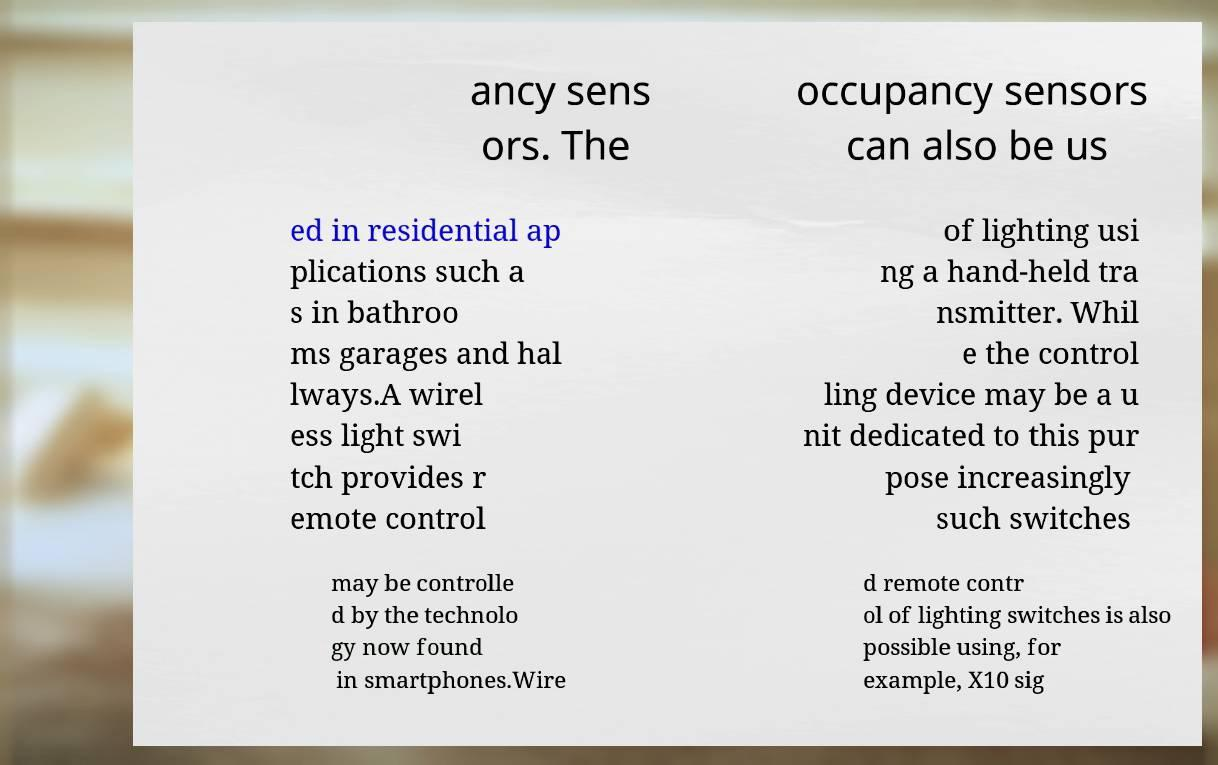There's text embedded in this image that I need extracted. Can you transcribe it verbatim? ancy sens ors. The occupancy sensors can also be us ed in residential ap plications such a s in bathroo ms garages and hal lways.A wirel ess light swi tch provides r emote control of lighting usi ng a hand-held tra nsmitter. Whil e the control ling device may be a u nit dedicated to this pur pose increasingly such switches may be controlle d by the technolo gy now found in smartphones.Wire d remote contr ol of lighting switches is also possible using, for example, X10 sig 